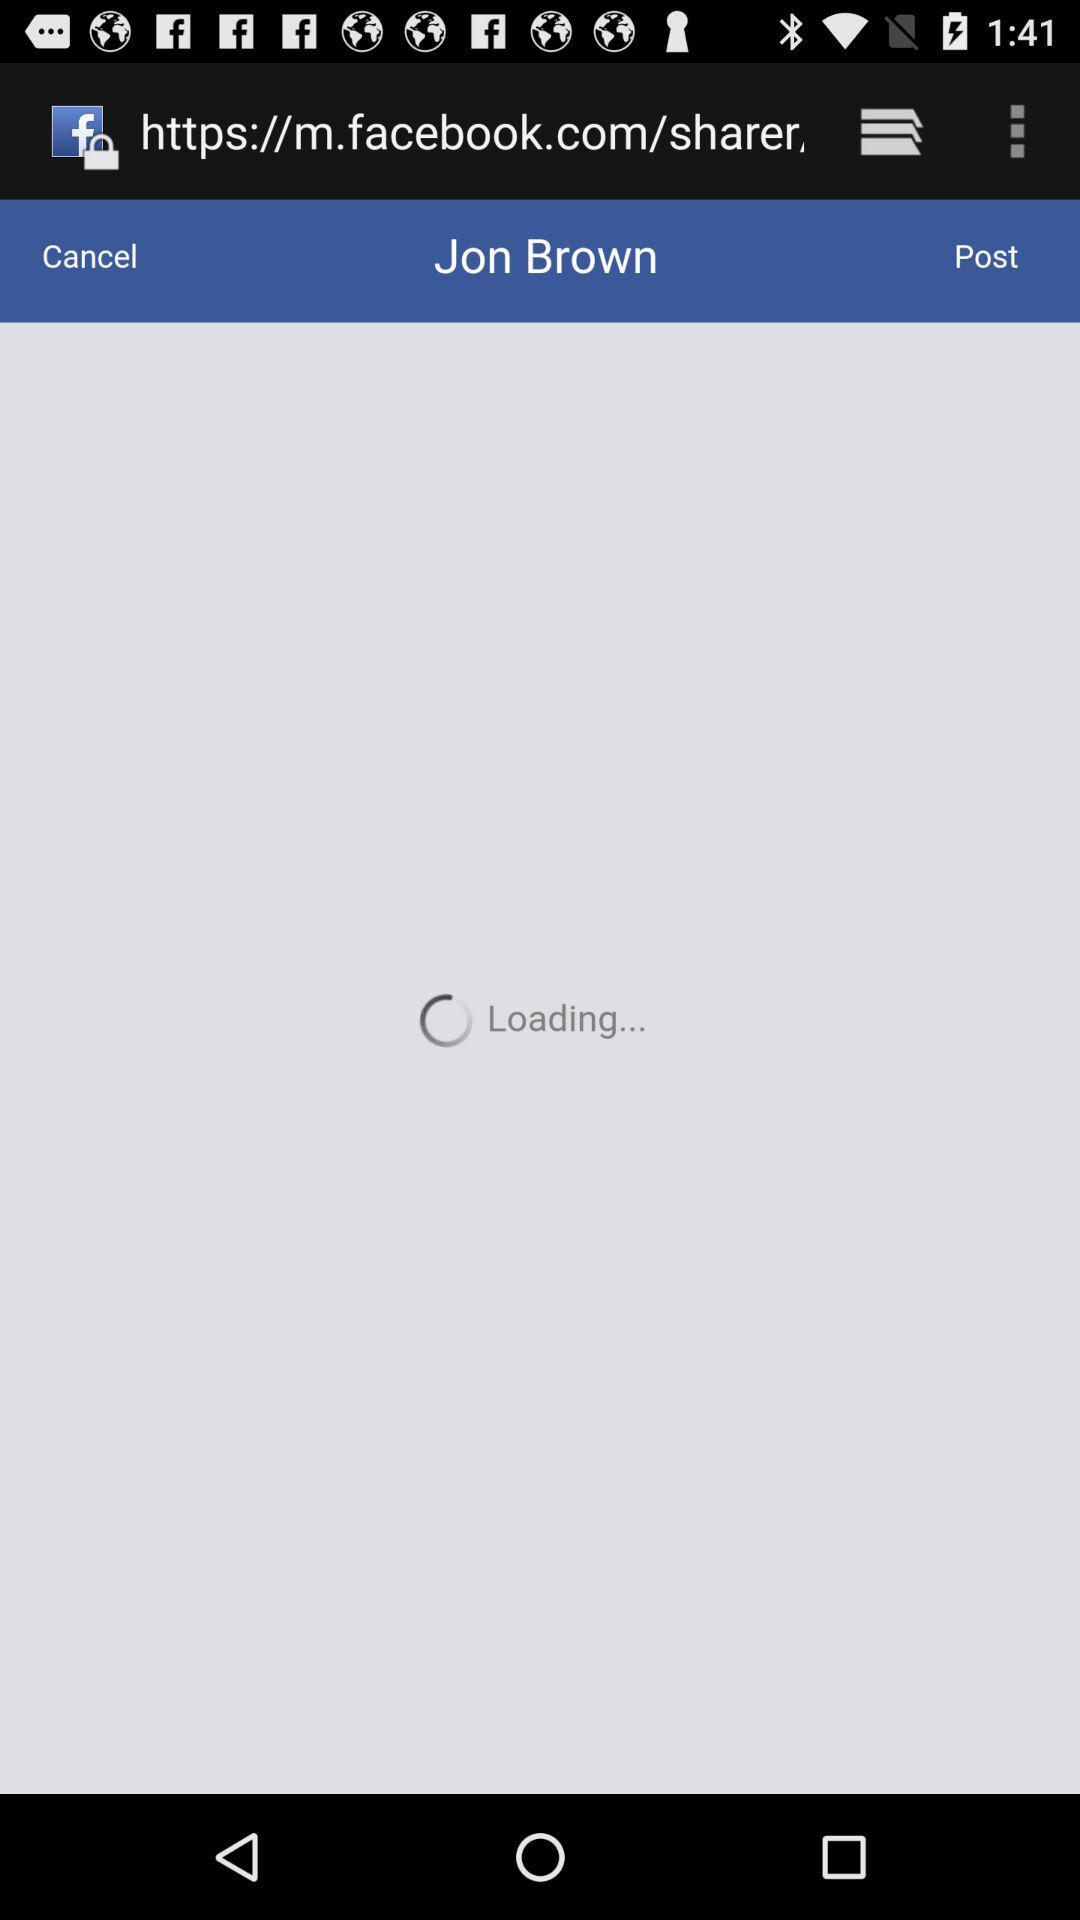When did Jon Brown make the last post?
When the provided information is insufficient, respond with <no answer>. <no answer> 